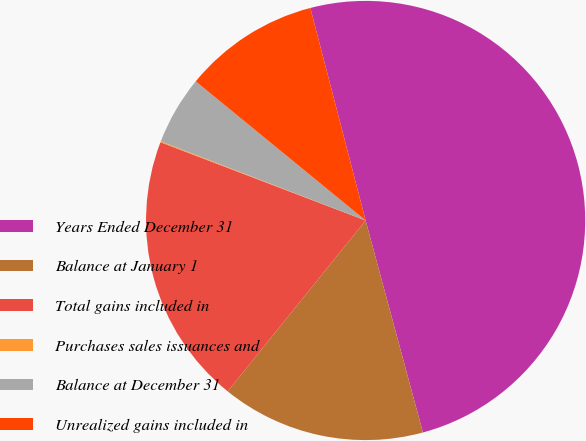Convert chart. <chart><loc_0><loc_0><loc_500><loc_500><pie_chart><fcel>Years Ended December 31<fcel>Balance at January 1<fcel>Total gains included in<fcel>Purchases sales issuances and<fcel>Balance at December 31<fcel>Unrealized gains included in<nl><fcel>49.85%<fcel>15.01%<fcel>19.99%<fcel>0.07%<fcel>5.05%<fcel>10.03%<nl></chart> 